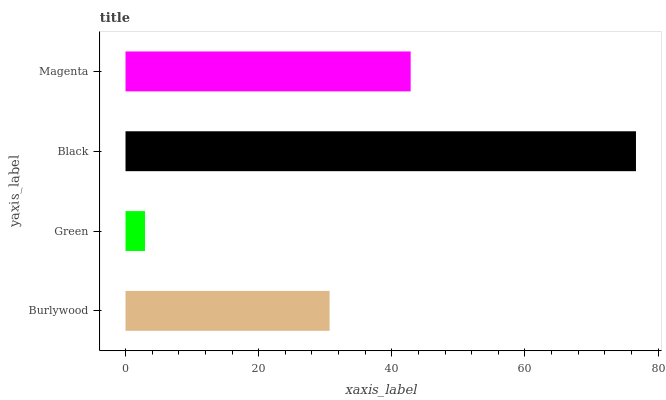Is Green the minimum?
Answer yes or no. Yes. Is Black the maximum?
Answer yes or no. Yes. Is Black the minimum?
Answer yes or no. No. Is Green the maximum?
Answer yes or no. No. Is Black greater than Green?
Answer yes or no. Yes. Is Green less than Black?
Answer yes or no. Yes. Is Green greater than Black?
Answer yes or no. No. Is Black less than Green?
Answer yes or no. No. Is Magenta the high median?
Answer yes or no. Yes. Is Burlywood the low median?
Answer yes or no. Yes. Is Black the high median?
Answer yes or no. No. Is Black the low median?
Answer yes or no. No. 